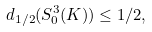Convert formula to latex. <formula><loc_0><loc_0><loc_500><loc_500>d _ { 1 / 2 } ( S ^ { 3 } _ { 0 } ( K ) ) \leq 1 / 2 ,</formula> 